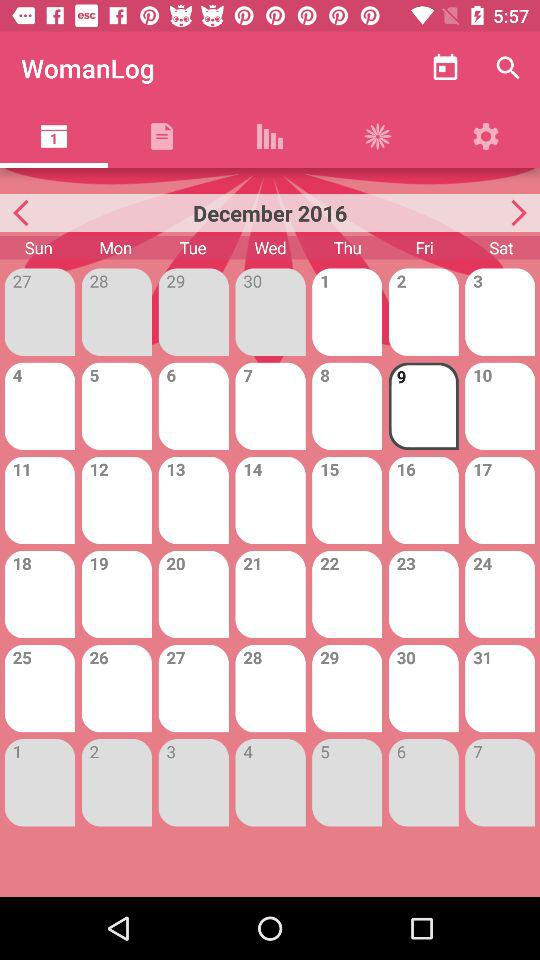What is the name of the application? The name of the application is "WomanLog". 